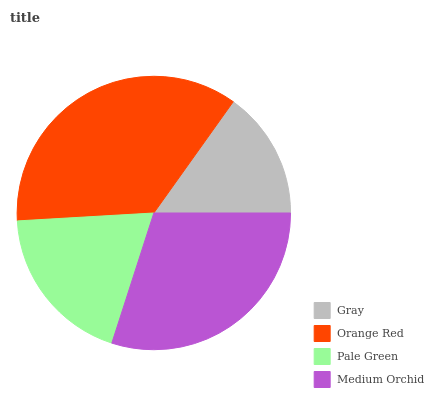Is Gray the minimum?
Answer yes or no. Yes. Is Orange Red the maximum?
Answer yes or no. Yes. Is Pale Green the minimum?
Answer yes or no. No. Is Pale Green the maximum?
Answer yes or no. No. Is Orange Red greater than Pale Green?
Answer yes or no. Yes. Is Pale Green less than Orange Red?
Answer yes or no. Yes. Is Pale Green greater than Orange Red?
Answer yes or no. No. Is Orange Red less than Pale Green?
Answer yes or no. No. Is Medium Orchid the high median?
Answer yes or no. Yes. Is Pale Green the low median?
Answer yes or no. Yes. Is Pale Green the high median?
Answer yes or no. No. Is Gray the low median?
Answer yes or no. No. 